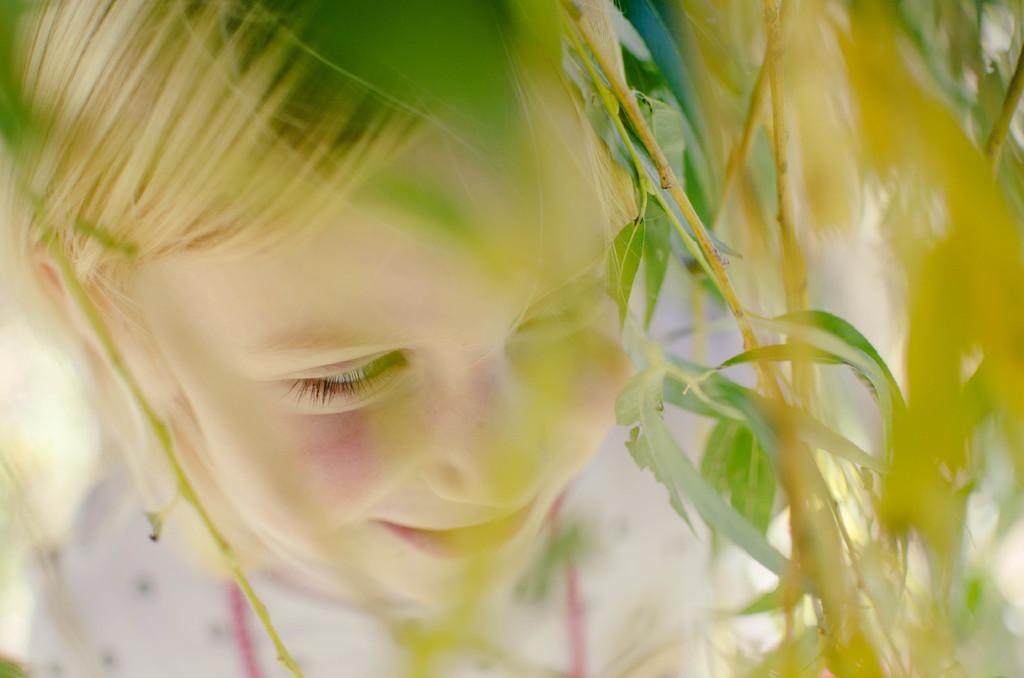What type of living organisms can be seen in the image? Plants can be seen in the image. Who is present in the image besides the plants? There is a girl in the image. What type of slip can be seen on the girl's hands in the image? There is no slip visible on the girl's hands in the image. What effect does the presence of the plants have on the girl in the image? The provided facts do not mention any effect the plants have on the girl, so we cannot determine an answer from the image. 